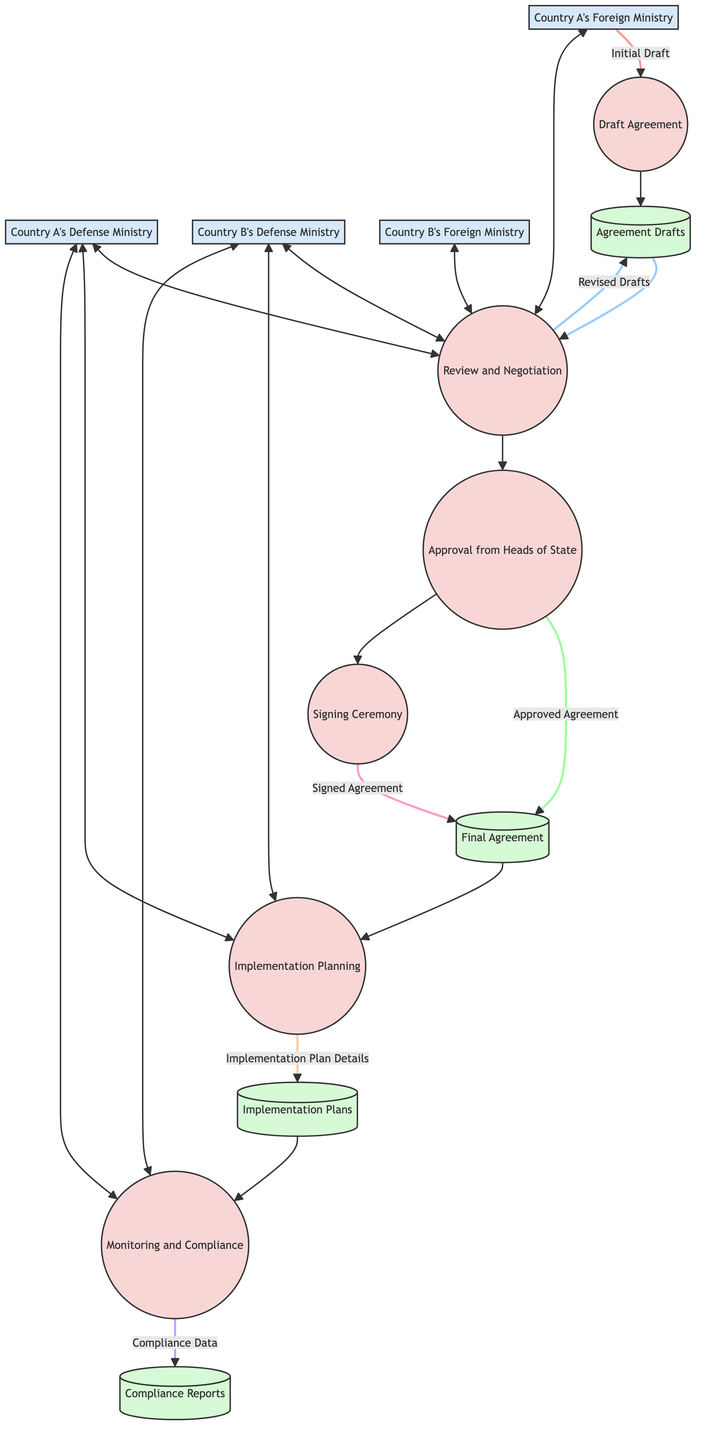What is the first process in the diagram? The first process listed in the diagram is "Draft Agreement," which is indicated as the initial step in the execution of the bilateral defense cooperation agreement.
Answer: Draft Agreement How many external entities are involved in the diagram? There are four external entities involved: Country A's Defense Ministry, Country B's Defense Ministry, Country A's Foreign Ministry, and Country B's Foreign Ministry. This can be counted directly from the external entities list in the diagram.
Answer: Four What does the "Monitoring and Compliance" process generate? The "Monitoring and Compliance" process generates "Compliance Data," which is specified as flowing from this process to the "Compliance Reports" data store in the diagram.
Answer: Compliance Data Which process follows the "Approval from Heads of State"? The process that follows "Approval from Heads of State" is the "Signing Ceremony," as indicated by the directional flow in the diagram between these two processes.
Answer: Signing Ceremony What type of document is stored in "Final Agreement"? The "Final Agreement" stores the "Signed Agreement," which is a clear indication seen in the flow from the "Signing Ceremony" process to the "Final Agreement" data store.
Answer: Signed Agreement What is the relationship between "Review and Negotiation" and "Draft Agreement"? The "Review and Negotiation" process utilizes the "Draft Agreement" as an input, creating a loop where revised drafts are generated and sent back to the "Agreement Drafts" data store.
Answer: Utilizes How many processes have a direct output to data stores? There are four processes with direct outputs to data stores: "Draft Agreement," "Approval from Heads of State," "Signing Ceremony," and "Implementation Planning," representing the processes that generate data useful for storage.
Answer: Four Which two ministries are involved in negotiating the draft agreement? The two ministries involved in negotiating the draft agreement are "Country A's Foreign Ministry" and "Country B's Foreign Ministry," as shown by the flow connecting these entities to the "Review and Negotiation" process.
Answer: Country A's Foreign Ministry and Country B's Foreign Ministry What is stored in "Compliance Reports"? The "Compliance Reports" data store holds the "Compliance Data," as indicated by the directional flow from the "Monitoring and Compliance" process to this data store in the diagram.
Answer: Compliance Data 